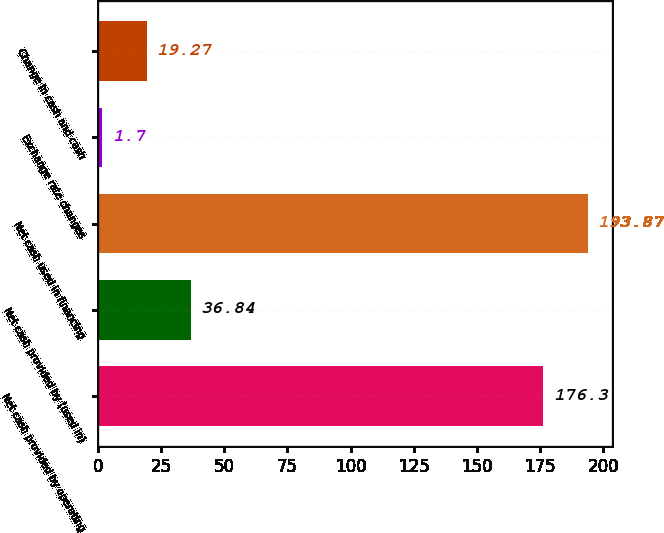Convert chart. <chart><loc_0><loc_0><loc_500><loc_500><bar_chart><fcel>Net cash provided by operating<fcel>Net cash provided by (used in)<fcel>Net cash used in financing<fcel>Exchange rate changes<fcel>Change in cash and cash<nl><fcel>176.3<fcel>36.84<fcel>193.87<fcel>1.7<fcel>19.27<nl></chart> 